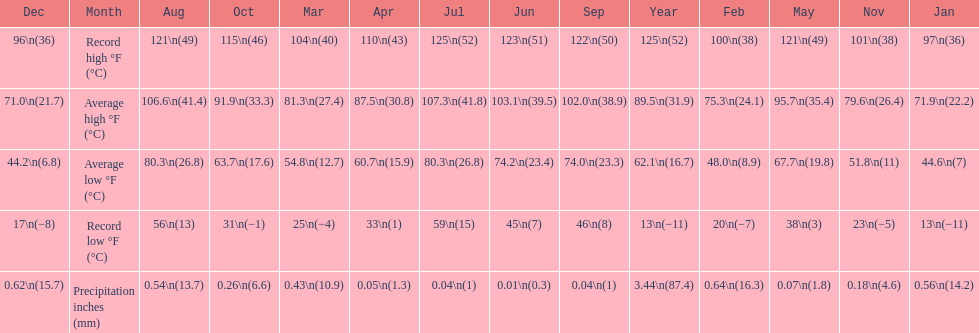How long was the monthly average temperature 100 degrees or more? 4 months. 